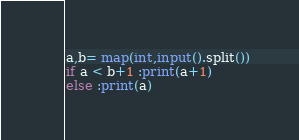<code> <loc_0><loc_0><loc_500><loc_500><_Python_>a,b= map(int,input().split())
if a < b+1 :print(a+1)
else :print(a)</code> 